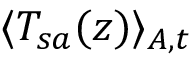<formula> <loc_0><loc_0><loc_500><loc_500>\langle T _ { s a } ( z ) \rangle _ { A , t }</formula> 